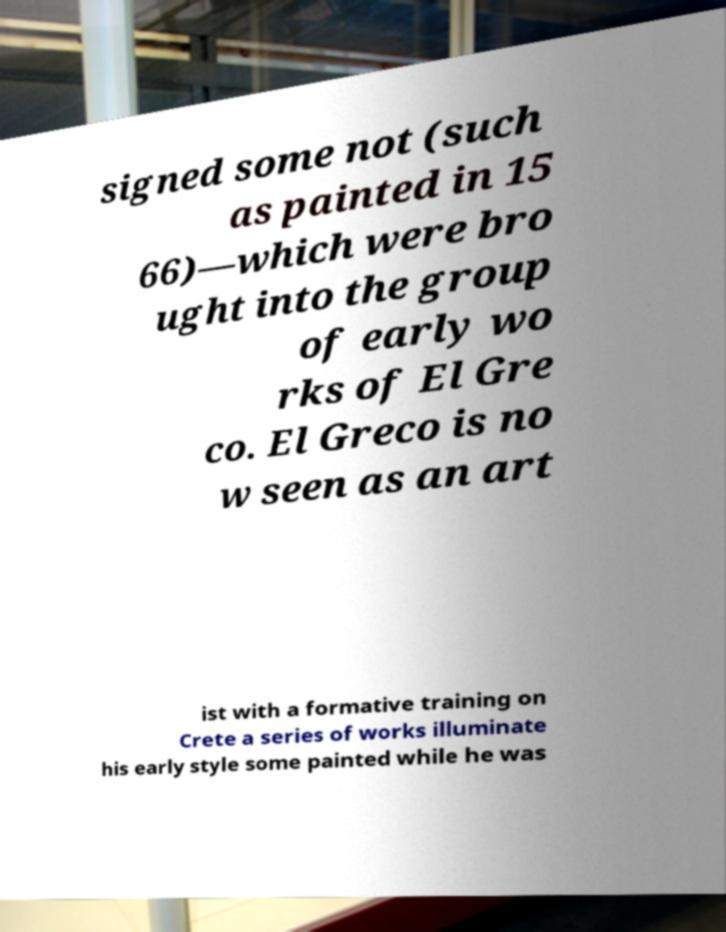There's text embedded in this image that I need extracted. Can you transcribe it verbatim? signed some not (such as painted in 15 66)—which were bro ught into the group of early wo rks of El Gre co. El Greco is no w seen as an art ist with a formative training on Crete a series of works illuminate his early style some painted while he was 